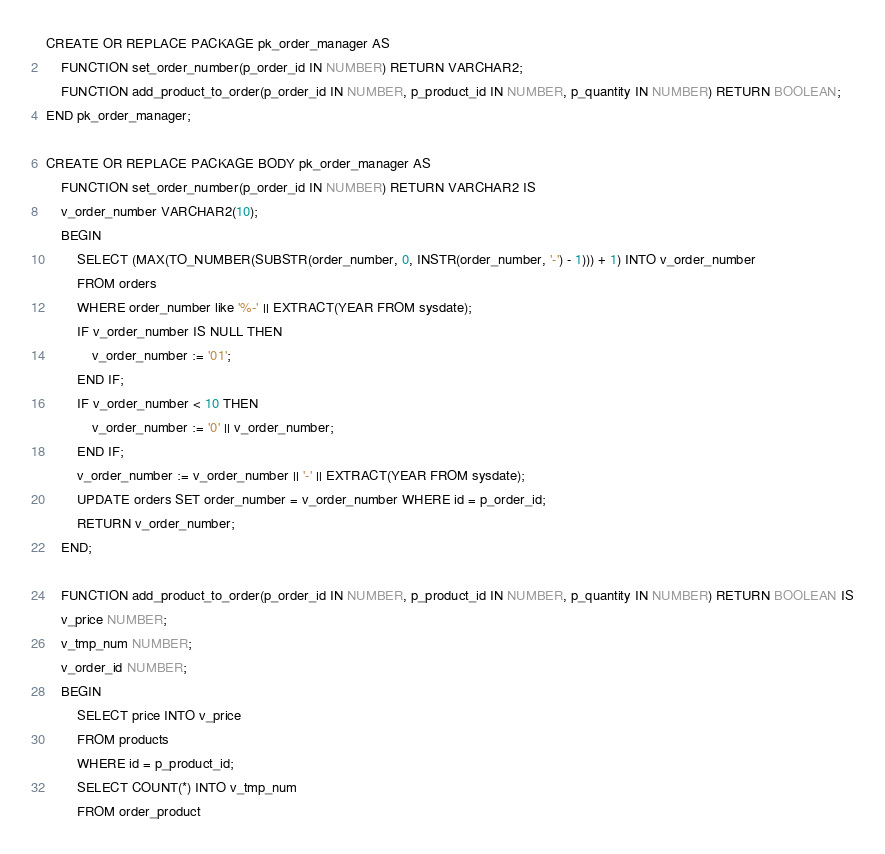Convert code to text. <code><loc_0><loc_0><loc_500><loc_500><_SQL_>CREATE OR REPLACE PACKAGE pk_order_manager AS
    FUNCTION set_order_number(p_order_id IN NUMBER) RETURN VARCHAR2;
    FUNCTION add_product_to_order(p_order_id IN NUMBER, p_product_id IN NUMBER, p_quantity IN NUMBER) RETURN BOOLEAN;
END pk_order_manager;

CREATE OR REPLACE PACKAGE BODY pk_order_manager AS
    FUNCTION set_order_number(p_order_id IN NUMBER) RETURN VARCHAR2 IS
    v_order_number VARCHAR2(10);
    BEGIN
        SELECT (MAX(TO_NUMBER(SUBSTR(order_number, 0, INSTR(order_number, '-') - 1))) + 1) INTO v_order_number
        FROM orders
        WHERE order_number like '%-' || EXTRACT(YEAR FROM sysdate);
        IF v_order_number IS NULL THEN
            v_order_number := '01';
        END IF;
        IF v_order_number < 10 THEN
            v_order_number := '0' || v_order_number;
        END IF;
        v_order_number := v_order_number || '-' || EXTRACT(YEAR FROM sysdate);
        UPDATE orders SET order_number = v_order_number WHERE id = p_order_id;
        RETURN v_order_number;
    END;
    
    FUNCTION add_product_to_order(p_order_id IN NUMBER, p_product_id IN NUMBER, p_quantity IN NUMBER) RETURN BOOLEAN IS
    v_price NUMBER;
    v_tmp_num NUMBER;
    v_order_id NUMBER;
    BEGIN
        SELECT price INTO v_price
        FROM products
        WHERE id = p_product_id;
        SELECT COUNT(*) INTO v_tmp_num
        FROM order_product</code> 